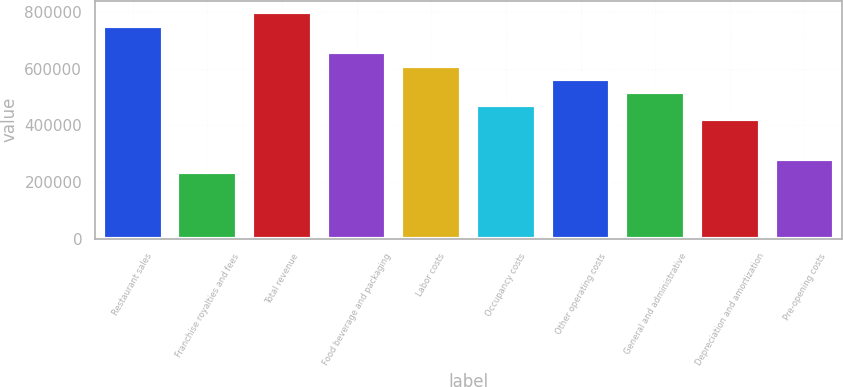Convert chart. <chart><loc_0><loc_0><loc_500><loc_500><bar_chart><fcel>Restaurant sales<fcel>Franchise royalties and fees<fcel>Total revenue<fcel>Food beverage and packaging<fcel>Labor costs<fcel>Occupancy costs<fcel>Other operating costs<fcel>General and administrative<fcel>Depreciation and amortization<fcel>Pre-opening costs<nl><fcel>753154<fcel>235361<fcel>800226<fcel>659009<fcel>611937<fcel>470721<fcel>564865<fcel>517793<fcel>423649<fcel>282433<nl></chart> 